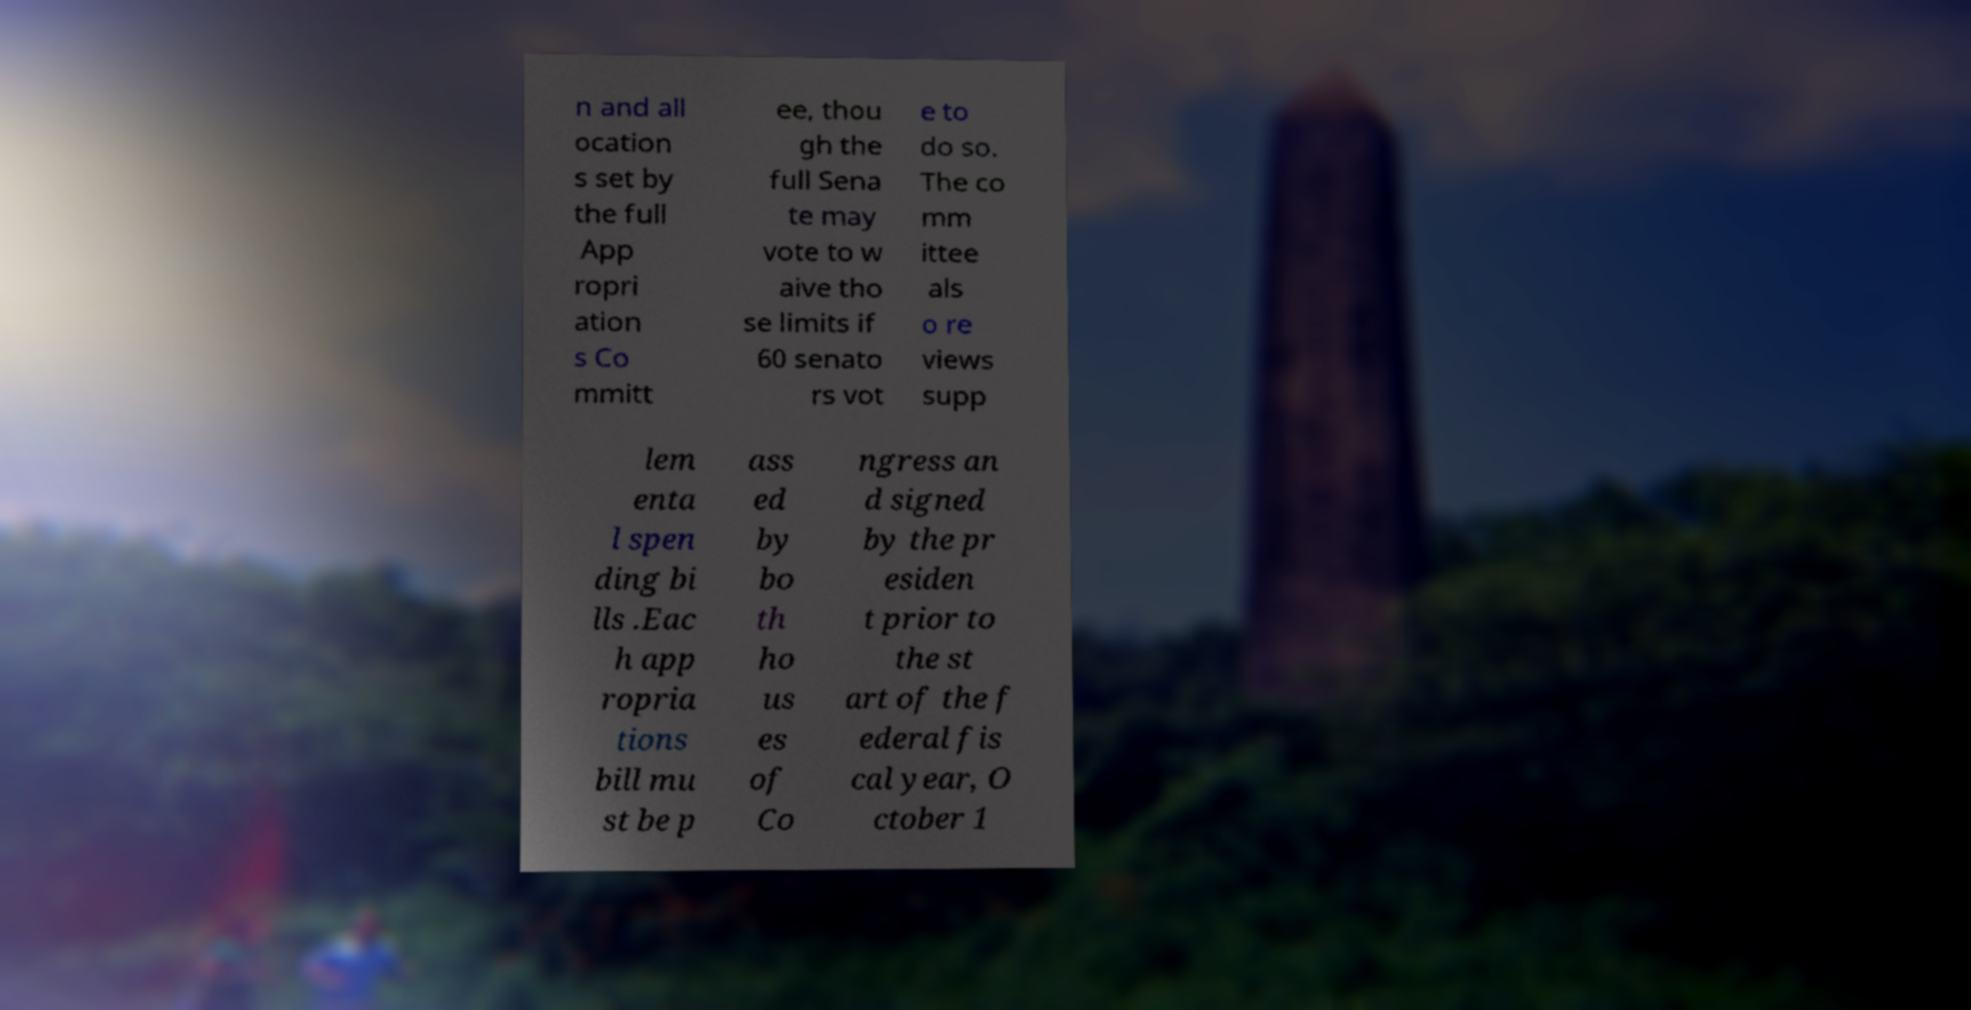I need the written content from this picture converted into text. Can you do that? n and all ocation s set by the full App ropri ation s Co mmitt ee, thou gh the full Sena te may vote to w aive tho se limits if 60 senato rs vot e to do so. The co mm ittee als o re views supp lem enta l spen ding bi lls .Eac h app ropria tions bill mu st be p ass ed by bo th ho us es of Co ngress an d signed by the pr esiden t prior to the st art of the f ederal fis cal year, O ctober 1 